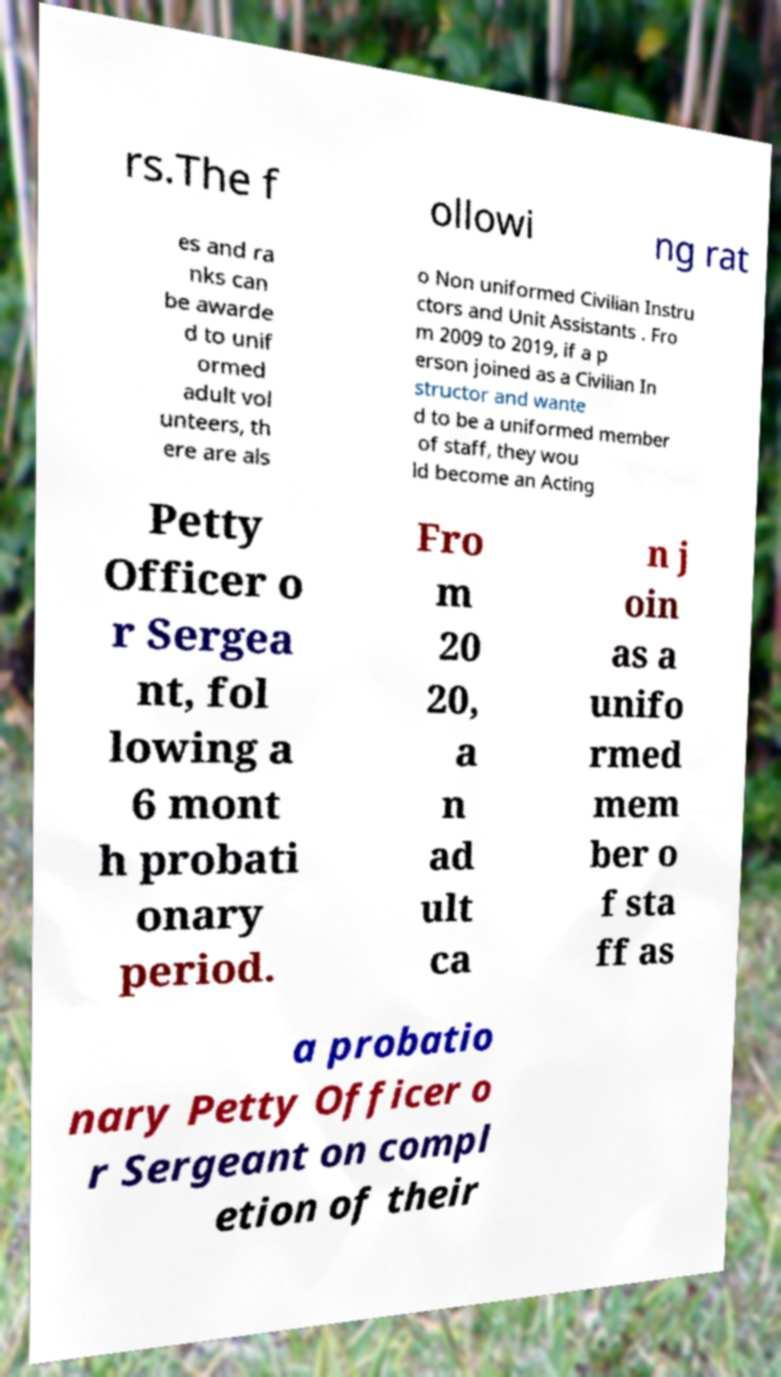Could you extract and type out the text from this image? rs.The f ollowi ng rat es and ra nks can be awarde d to unif ormed adult vol unteers, th ere are als o Non uniformed Civilian Instru ctors and Unit Assistants . Fro m 2009 to 2019, if a p erson joined as a Civilian In structor and wante d to be a uniformed member of staff, they wou ld become an Acting Petty Officer o r Sergea nt, fol lowing a 6 mont h probati onary period. Fro m 20 20, a n ad ult ca n j oin as a unifo rmed mem ber o f sta ff as a probatio nary Petty Officer o r Sergeant on compl etion of their 